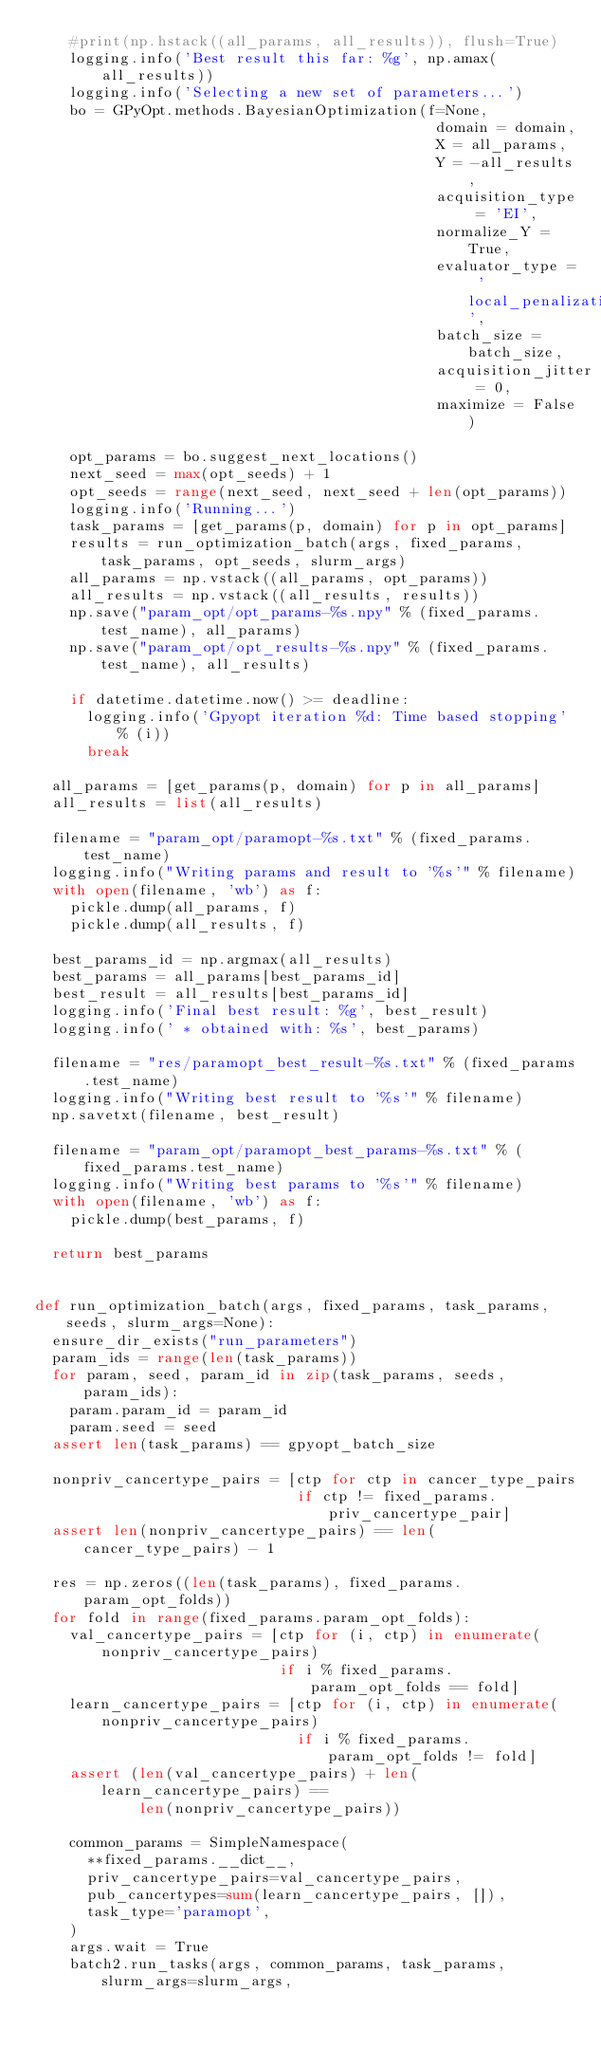Convert code to text. <code><loc_0><loc_0><loc_500><loc_500><_Python_>    #print(np.hstack((all_params, all_results)), flush=True)
    logging.info('Best result this far: %g', np.amax(all_results))
    logging.info('Selecting a new set of parameters...')
    bo = GPyOpt.methods.BayesianOptimization(f=None,
                                              domain = domain,
                                              X = all_params,
                                              Y = -all_results,
                                              acquisition_type = 'EI',
                                              normalize_Y = True,
                                              evaluator_type = 'local_penalization',
                                              batch_size = batch_size,
                                              acquisition_jitter = 0,
                                              maximize = False)

    opt_params = bo.suggest_next_locations()
    next_seed = max(opt_seeds) + 1
    opt_seeds = range(next_seed, next_seed + len(opt_params))
    logging.info('Running...')
    task_params = [get_params(p, domain) for p in opt_params]
    results = run_optimization_batch(args, fixed_params, task_params, opt_seeds, slurm_args)
    all_params = np.vstack((all_params, opt_params))
    all_results = np.vstack((all_results, results))
    np.save("param_opt/opt_params-%s.npy" % (fixed_params.test_name), all_params)
    np.save("param_opt/opt_results-%s.npy" % (fixed_params.test_name), all_results)

    if datetime.datetime.now() >= deadline:
      logging.info('Gpyopt iteration %d: Time based stopping' % (i))
      break

  all_params = [get_params(p, domain) for p in all_params]
  all_results = list(all_results)

  filename = "param_opt/paramopt-%s.txt" % (fixed_params.test_name)
  logging.info("Writing params and result to '%s'" % filename)
  with open(filename, 'wb') as f:
    pickle.dump(all_params, f)
    pickle.dump(all_results, f)

  best_params_id = np.argmax(all_results)
  best_params = all_params[best_params_id]
  best_result = all_results[best_params_id]
  logging.info('Final best result: %g', best_result)
  logging.info(' * obtained with: %s', best_params)

  filename = "res/paramopt_best_result-%s.txt" % (fixed_params.test_name)
  logging.info("Writing best result to '%s'" % filename)
  np.savetxt(filename, best_result)

  filename = "param_opt/paramopt_best_params-%s.txt" % (fixed_params.test_name)
  logging.info("Writing best params to '%s'" % filename)
  with open(filename, 'wb') as f:
    pickle.dump(best_params, f)

  return best_params


def run_optimization_batch(args, fixed_params, task_params, seeds, slurm_args=None):
  ensure_dir_exists("run_parameters")
  param_ids = range(len(task_params))
  for param, seed, param_id in zip(task_params, seeds, param_ids):
    param.param_id = param_id
    param.seed = seed
  assert len(task_params) == gpyopt_batch_size

  nonpriv_cancertype_pairs = [ctp for ctp in cancer_type_pairs
                              if ctp != fixed_params.priv_cancertype_pair]
  assert len(nonpriv_cancertype_pairs) == len(cancer_type_pairs) - 1

  res = np.zeros((len(task_params), fixed_params.param_opt_folds))
  for fold in range(fixed_params.param_opt_folds):
    val_cancertype_pairs = [ctp for (i, ctp) in enumerate(nonpriv_cancertype_pairs)
                            if i % fixed_params.param_opt_folds == fold]
    learn_cancertype_pairs = [ctp for (i, ctp) in enumerate(nonpriv_cancertype_pairs)
                              if i % fixed_params.param_opt_folds != fold]
    assert (len(val_cancertype_pairs) + len(learn_cancertype_pairs) ==
            len(nonpriv_cancertype_pairs))
    
    common_params = SimpleNamespace(
      **fixed_params.__dict__,
      priv_cancertype_pairs=val_cancertype_pairs,
      pub_cancertypes=sum(learn_cancertype_pairs, []),
      task_type='paramopt',
    )
    args.wait = True
    batch2.run_tasks(args, common_params, task_params, slurm_args=slurm_args,</code> 